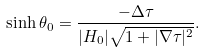<formula> <loc_0><loc_0><loc_500><loc_500>\sinh \theta _ { 0 } = \frac { - \Delta \tau } { | H _ { 0 } | \sqrt { 1 + | \nabla \tau | ^ { 2 } } } .</formula> 